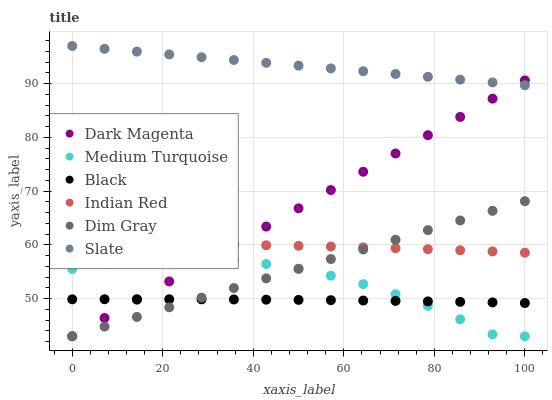Does Black have the minimum area under the curve?
Answer yes or no. Yes. Does Slate have the maximum area under the curve?
Answer yes or no. Yes. Does Dim Gray have the minimum area under the curve?
Answer yes or no. No. Does Dim Gray have the maximum area under the curve?
Answer yes or no. No. Is Dim Gray the smoothest?
Answer yes or no. Yes. Is Medium Turquoise the roughest?
Answer yes or no. Yes. Is Dark Magenta the smoothest?
Answer yes or no. No. Is Dark Magenta the roughest?
Answer yes or no. No. Does Medium Turquoise have the lowest value?
Answer yes or no. Yes. Does Slate have the lowest value?
Answer yes or no. No. Does Slate have the highest value?
Answer yes or no. Yes. Does Dim Gray have the highest value?
Answer yes or no. No. Is Dim Gray less than Slate?
Answer yes or no. Yes. Is Slate greater than Medium Turquoise?
Answer yes or no. Yes. Does Dim Gray intersect Medium Turquoise?
Answer yes or no. Yes. Is Dim Gray less than Medium Turquoise?
Answer yes or no. No. Is Dim Gray greater than Medium Turquoise?
Answer yes or no. No. Does Dim Gray intersect Slate?
Answer yes or no. No. 